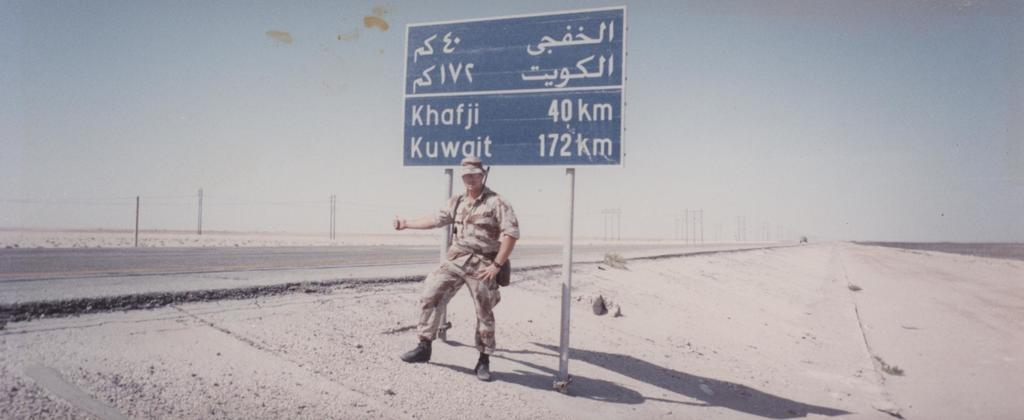<image>
Summarize the visual content of the image. A solider standings next to a sign that says Khafji 40 km written on it. 